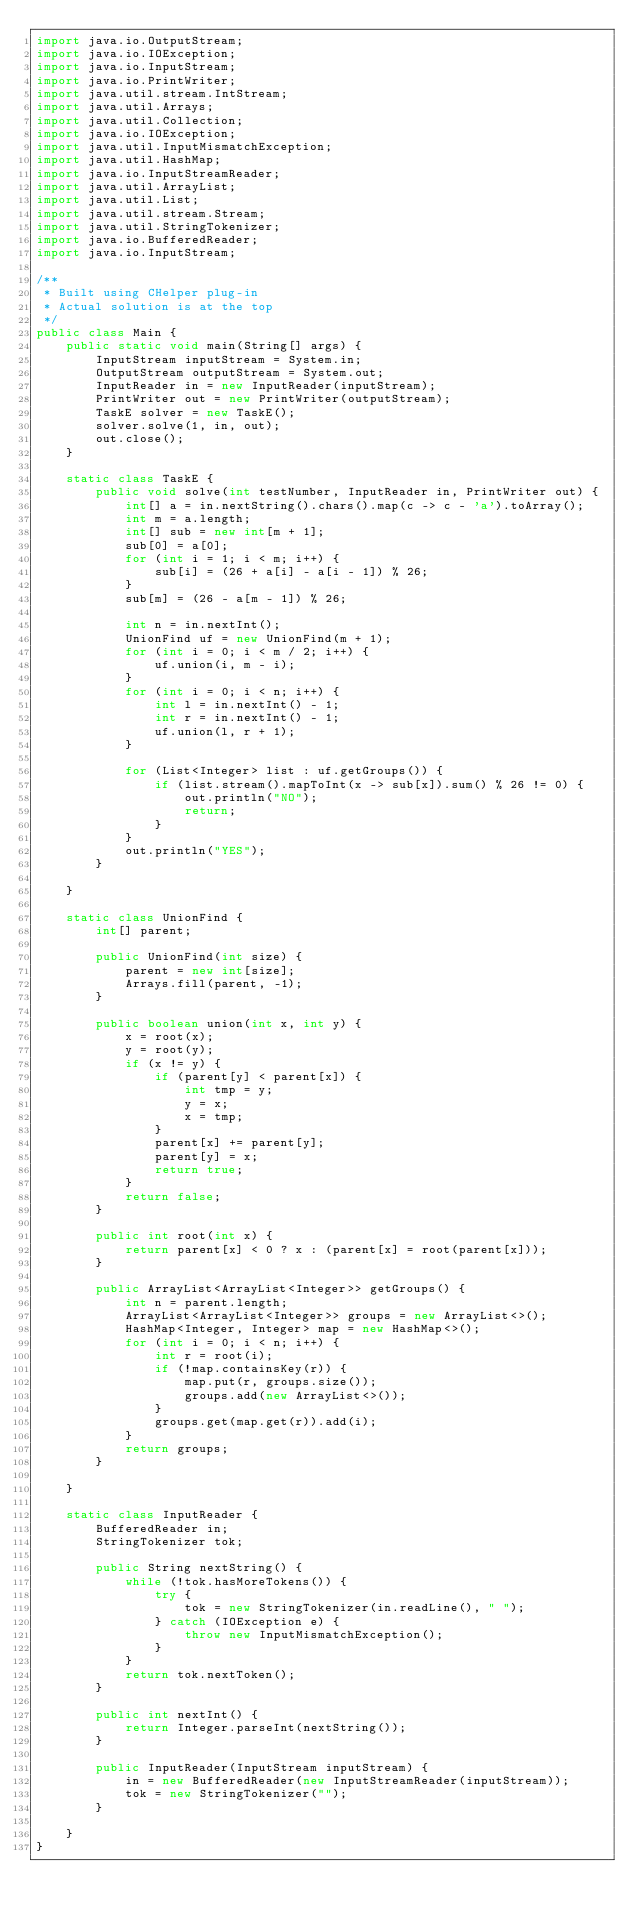Convert code to text. <code><loc_0><loc_0><loc_500><loc_500><_Java_>import java.io.OutputStream;
import java.io.IOException;
import java.io.InputStream;
import java.io.PrintWriter;
import java.util.stream.IntStream;
import java.util.Arrays;
import java.util.Collection;
import java.io.IOException;
import java.util.InputMismatchException;
import java.util.HashMap;
import java.io.InputStreamReader;
import java.util.ArrayList;
import java.util.List;
import java.util.stream.Stream;
import java.util.StringTokenizer;
import java.io.BufferedReader;
import java.io.InputStream;

/**
 * Built using CHelper plug-in
 * Actual solution is at the top
 */
public class Main {
    public static void main(String[] args) {
        InputStream inputStream = System.in;
        OutputStream outputStream = System.out;
        InputReader in = new InputReader(inputStream);
        PrintWriter out = new PrintWriter(outputStream);
        TaskE solver = new TaskE();
        solver.solve(1, in, out);
        out.close();
    }

    static class TaskE {
        public void solve(int testNumber, InputReader in, PrintWriter out) {
            int[] a = in.nextString().chars().map(c -> c - 'a').toArray();
            int m = a.length;
            int[] sub = new int[m + 1];
            sub[0] = a[0];
            for (int i = 1; i < m; i++) {
                sub[i] = (26 + a[i] - a[i - 1]) % 26;
            }
            sub[m] = (26 - a[m - 1]) % 26;

            int n = in.nextInt();
            UnionFind uf = new UnionFind(m + 1);
            for (int i = 0; i < m / 2; i++) {
                uf.union(i, m - i);
            }
            for (int i = 0; i < n; i++) {
                int l = in.nextInt() - 1;
                int r = in.nextInt() - 1;
                uf.union(l, r + 1);
            }

            for (List<Integer> list : uf.getGroups()) {
                if (list.stream().mapToInt(x -> sub[x]).sum() % 26 != 0) {
                    out.println("NO");
                    return;
                }
            }
            out.println("YES");
        }

    }

    static class UnionFind {
        int[] parent;

        public UnionFind(int size) {
            parent = new int[size];
            Arrays.fill(parent, -1);
        }

        public boolean union(int x, int y) {
            x = root(x);
            y = root(y);
            if (x != y) {
                if (parent[y] < parent[x]) {
                    int tmp = y;
                    y = x;
                    x = tmp;
                }
                parent[x] += parent[y];
                parent[y] = x;
                return true;
            }
            return false;
        }

        public int root(int x) {
            return parent[x] < 0 ? x : (parent[x] = root(parent[x]));
        }

        public ArrayList<ArrayList<Integer>> getGroups() {
            int n = parent.length;
            ArrayList<ArrayList<Integer>> groups = new ArrayList<>();
            HashMap<Integer, Integer> map = new HashMap<>();
            for (int i = 0; i < n; i++) {
                int r = root(i);
                if (!map.containsKey(r)) {
                    map.put(r, groups.size());
                    groups.add(new ArrayList<>());
                }
                groups.get(map.get(r)).add(i);
            }
            return groups;
        }

    }

    static class InputReader {
        BufferedReader in;
        StringTokenizer tok;

        public String nextString() {
            while (!tok.hasMoreTokens()) {
                try {
                    tok = new StringTokenizer(in.readLine(), " ");
                } catch (IOException e) {
                    throw new InputMismatchException();
                }
            }
            return tok.nextToken();
        }

        public int nextInt() {
            return Integer.parseInt(nextString());
        }

        public InputReader(InputStream inputStream) {
            in = new BufferedReader(new InputStreamReader(inputStream));
            tok = new StringTokenizer("");
        }

    }
}

</code> 